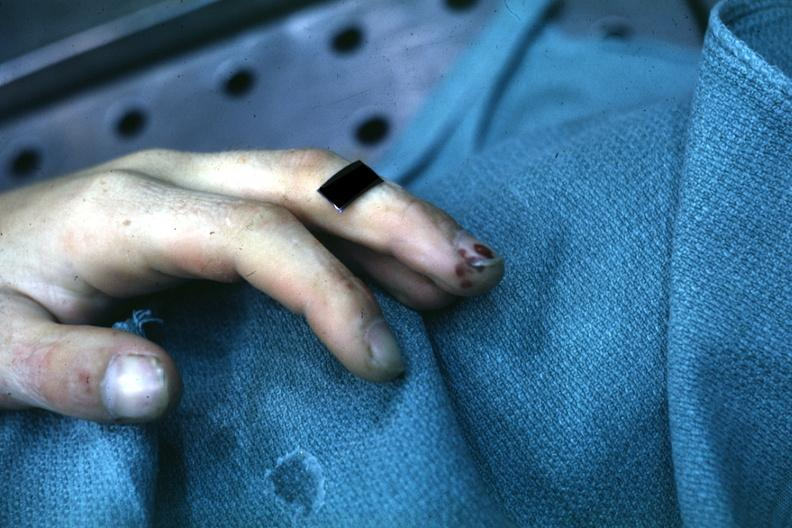does surface show lesions well shown on index finger staphylococcus?
Answer the question using a single word or phrase. No 